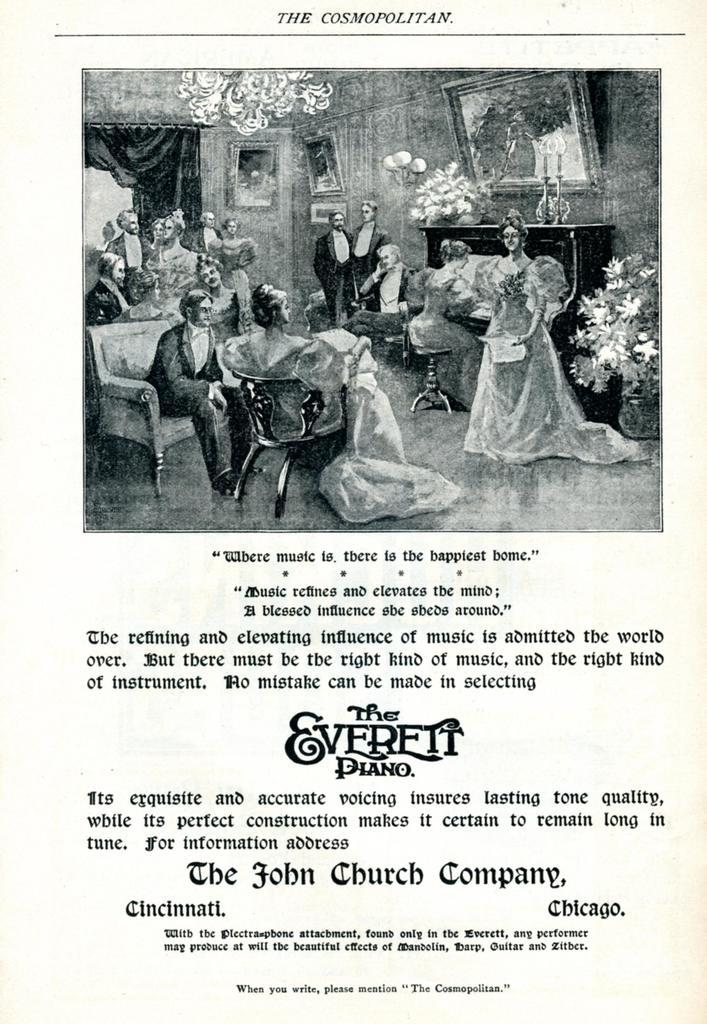What is the main subject of the image? The main subject of the image is a page. What is depicted on the page? The page contains a photograph. Are there any words on the page? Yes, there is text on the page. How many trees can be seen in the photograph on the page? There is no photograph of trees in the image; the photograph on the page cannot be determined from the provided facts. 